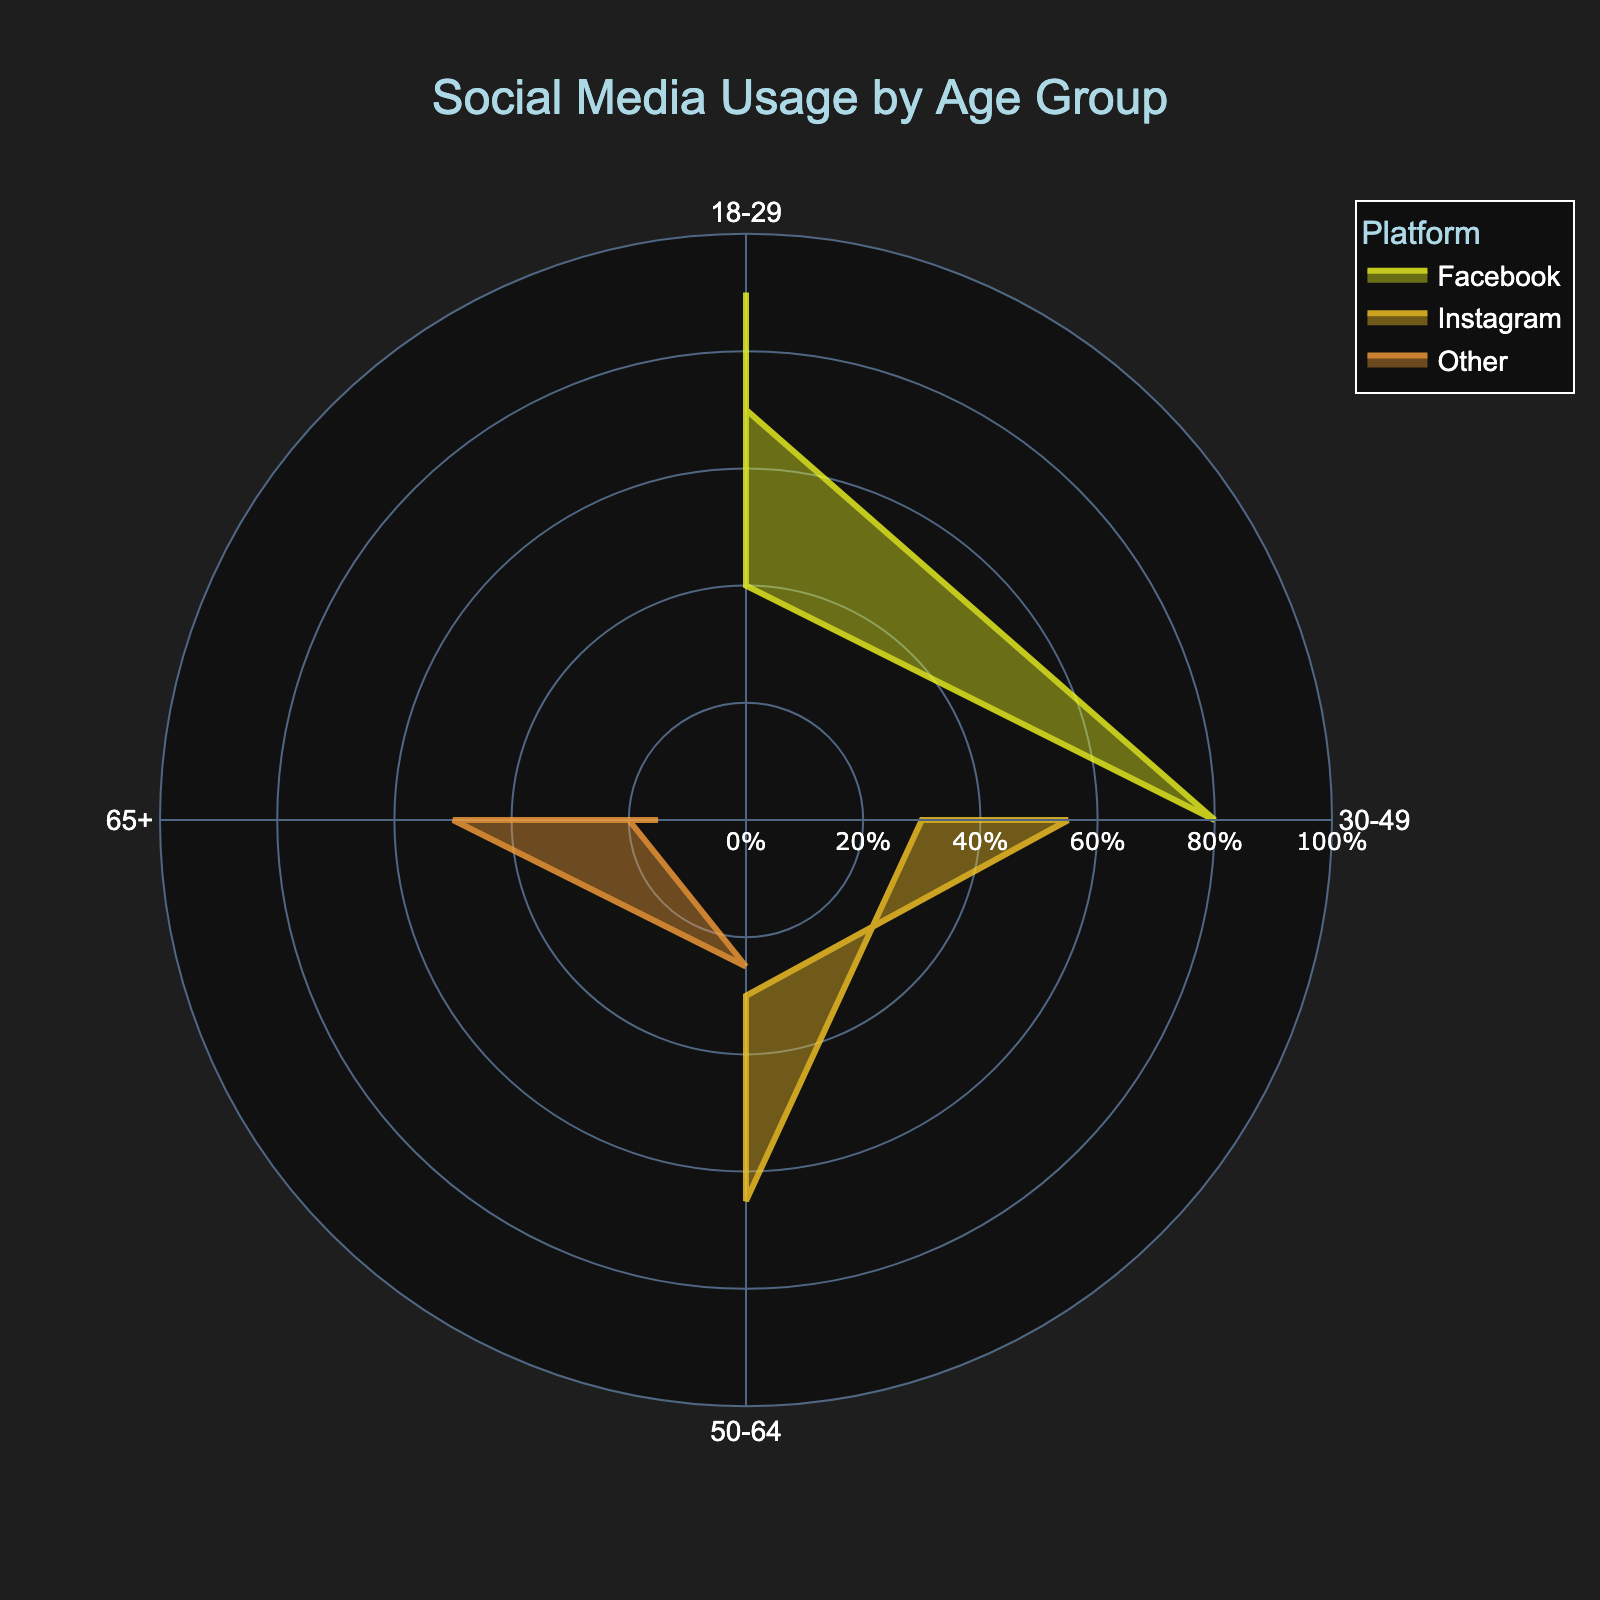What is the title of the figure? The title is shown at the top of the figure and provides a high-level description of the data being visualized. The title reads "Social Media Usage by Age Group".
Answer: Social Media Usage by Age Group Which age group has the highest usage percentage on Instagram? To determine this, we look at the section of the rose chart related to Instagram and identify the segment with the longest radial line in that category. The segment for the 18-29 age group extends the furthest.
Answer: 18-29 What is the difference in Facebook usage percentage between the 18-29 and 65+ age groups? We check the lengths of the radial lines for Facebook usage in both the 18-29 and 65+ age groups. The 18-29 group is at 70%, and the 65+ group is at 50%. The difference is 70% - 50%.
Answer: 20% Which platform has the lowest usage percentage in the 50-64 age group? By examining the segments for the 50-64 age group, we see that Instagram and Other are shorter compared to Facebook. Out of these, the 'Other' category has the shortest segment indicating the lowest usage.
Answer: Other How does the Instagram usage for the 30-49 age group compare to the Facebook usage for the 18-29 age group? For this comparison, we observe the radial lines for Instagram in the 30-49 age group and Facebook in the 18-29 age group. The Instagram usage for the 30-49 group is at 55%, whereas the Facebook usage for the 18-29 group is at 70%, meaning the former is lower than the latter.
Answer: Lower Which age group has the most even distribution across all three platforms? Here, we need to compare the lengths of the radial lines for each platform within each age group. The 50-64 age group has relatively balanced segments with values of 65% for Facebook, 30% for Instagram, and 25% for Other, which shows a more even distribution compared to others.
Answer: 50-64 What is the total usage percentage across all platforms for the 18-29 age group? We sum the usage percentages of Facebook, Instagram, and Other for the 18-29 age group. This equals 70% (Facebook) + 90% (Instagram) + 40% (Other) = 200%.
Answer: 200% What is the average usage percentage of Instagram across all age groups? To find the average, add the Instagram usage percentages for all age groups and divide by the number of groups: (90% + 55% + 30% + 15%) / 4 = 47.5%.
Answer: 47.5% Is there an age group where the usage of 'Other' social media platforms exceeds that of Facebook? We compare the 'Other' usage percentage with the 'Facebook' usage percentage in each age group. In every age group, the Facebook usage percentage is higher than 'Other', so there is no such group.
Answer: No 